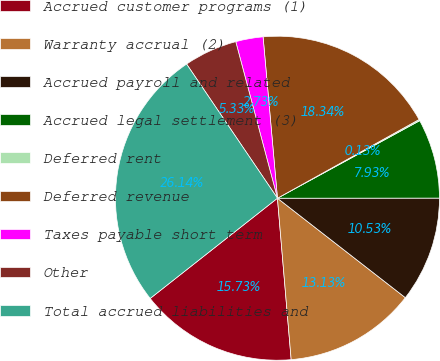Convert chart to OTSL. <chart><loc_0><loc_0><loc_500><loc_500><pie_chart><fcel>Accrued customer programs (1)<fcel>Warranty accrual (2)<fcel>Accrued payroll and related<fcel>Accrued legal settlement (3)<fcel>Deferred rent<fcel>Deferred revenue<fcel>Taxes payable short term<fcel>Other<fcel>Total accrued liabilities and<nl><fcel>15.73%<fcel>13.13%<fcel>10.53%<fcel>7.93%<fcel>0.13%<fcel>18.34%<fcel>2.73%<fcel>5.33%<fcel>26.14%<nl></chart> 